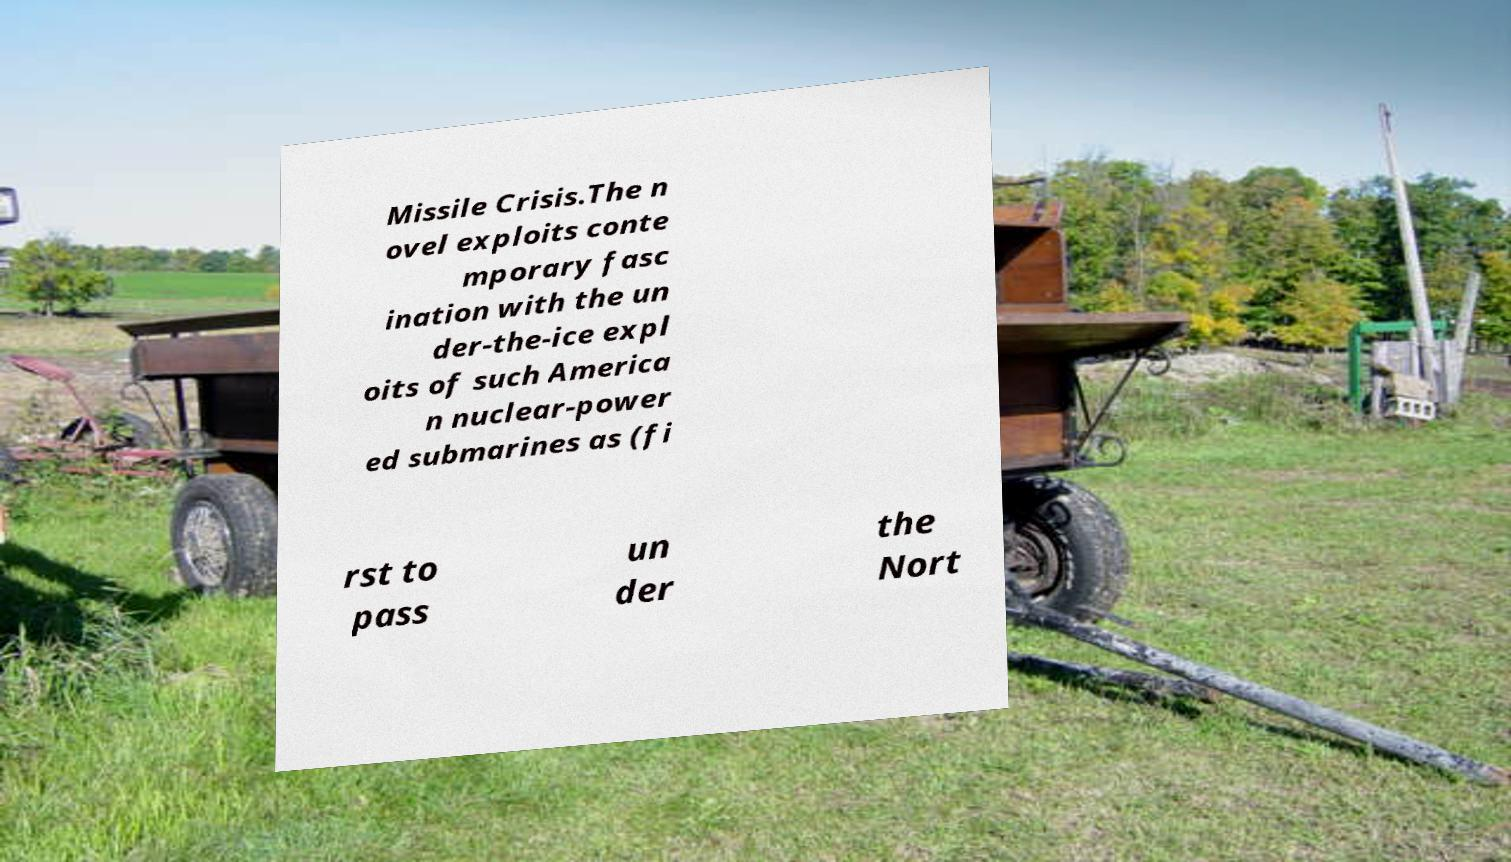Please read and relay the text visible in this image. What does it say? Missile Crisis.The n ovel exploits conte mporary fasc ination with the un der-the-ice expl oits of such America n nuclear-power ed submarines as (fi rst to pass un der the Nort 